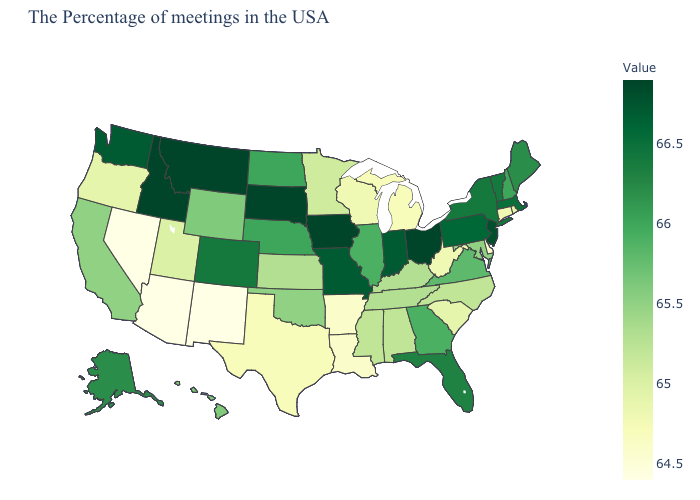Does Florida have a higher value than Nevada?
Give a very brief answer. Yes. Is the legend a continuous bar?
Answer briefly. Yes. Does the map have missing data?
Short answer required. No. Which states have the lowest value in the USA?
Quick response, please. New Mexico, Arizona, Nevada. 